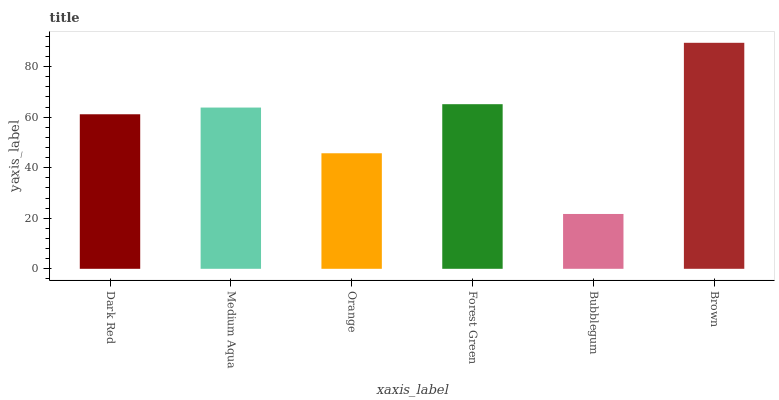Is Bubblegum the minimum?
Answer yes or no. Yes. Is Brown the maximum?
Answer yes or no. Yes. Is Medium Aqua the minimum?
Answer yes or no. No. Is Medium Aqua the maximum?
Answer yes or no. No. Is Medium Aqua greater than Dark Red?
Answer yes or no. Yes. Is Dark Red less than Medium Aqua?
Answer yes or no. Yes. Is Dark Red greater than Medium Aqua?
Answer yes or no. No. Is Medium Aqua less than Dark Red?
Answer yes or no. No. Is Medium Aqua the high median?
Answer yes or no. Yes. Is Dark Red the low median?
Answer yes or no. Yes. Is Dark Red the high median?
Answer yes or no. No. Is Forest Green the low median?
Answer yes or no. No. 